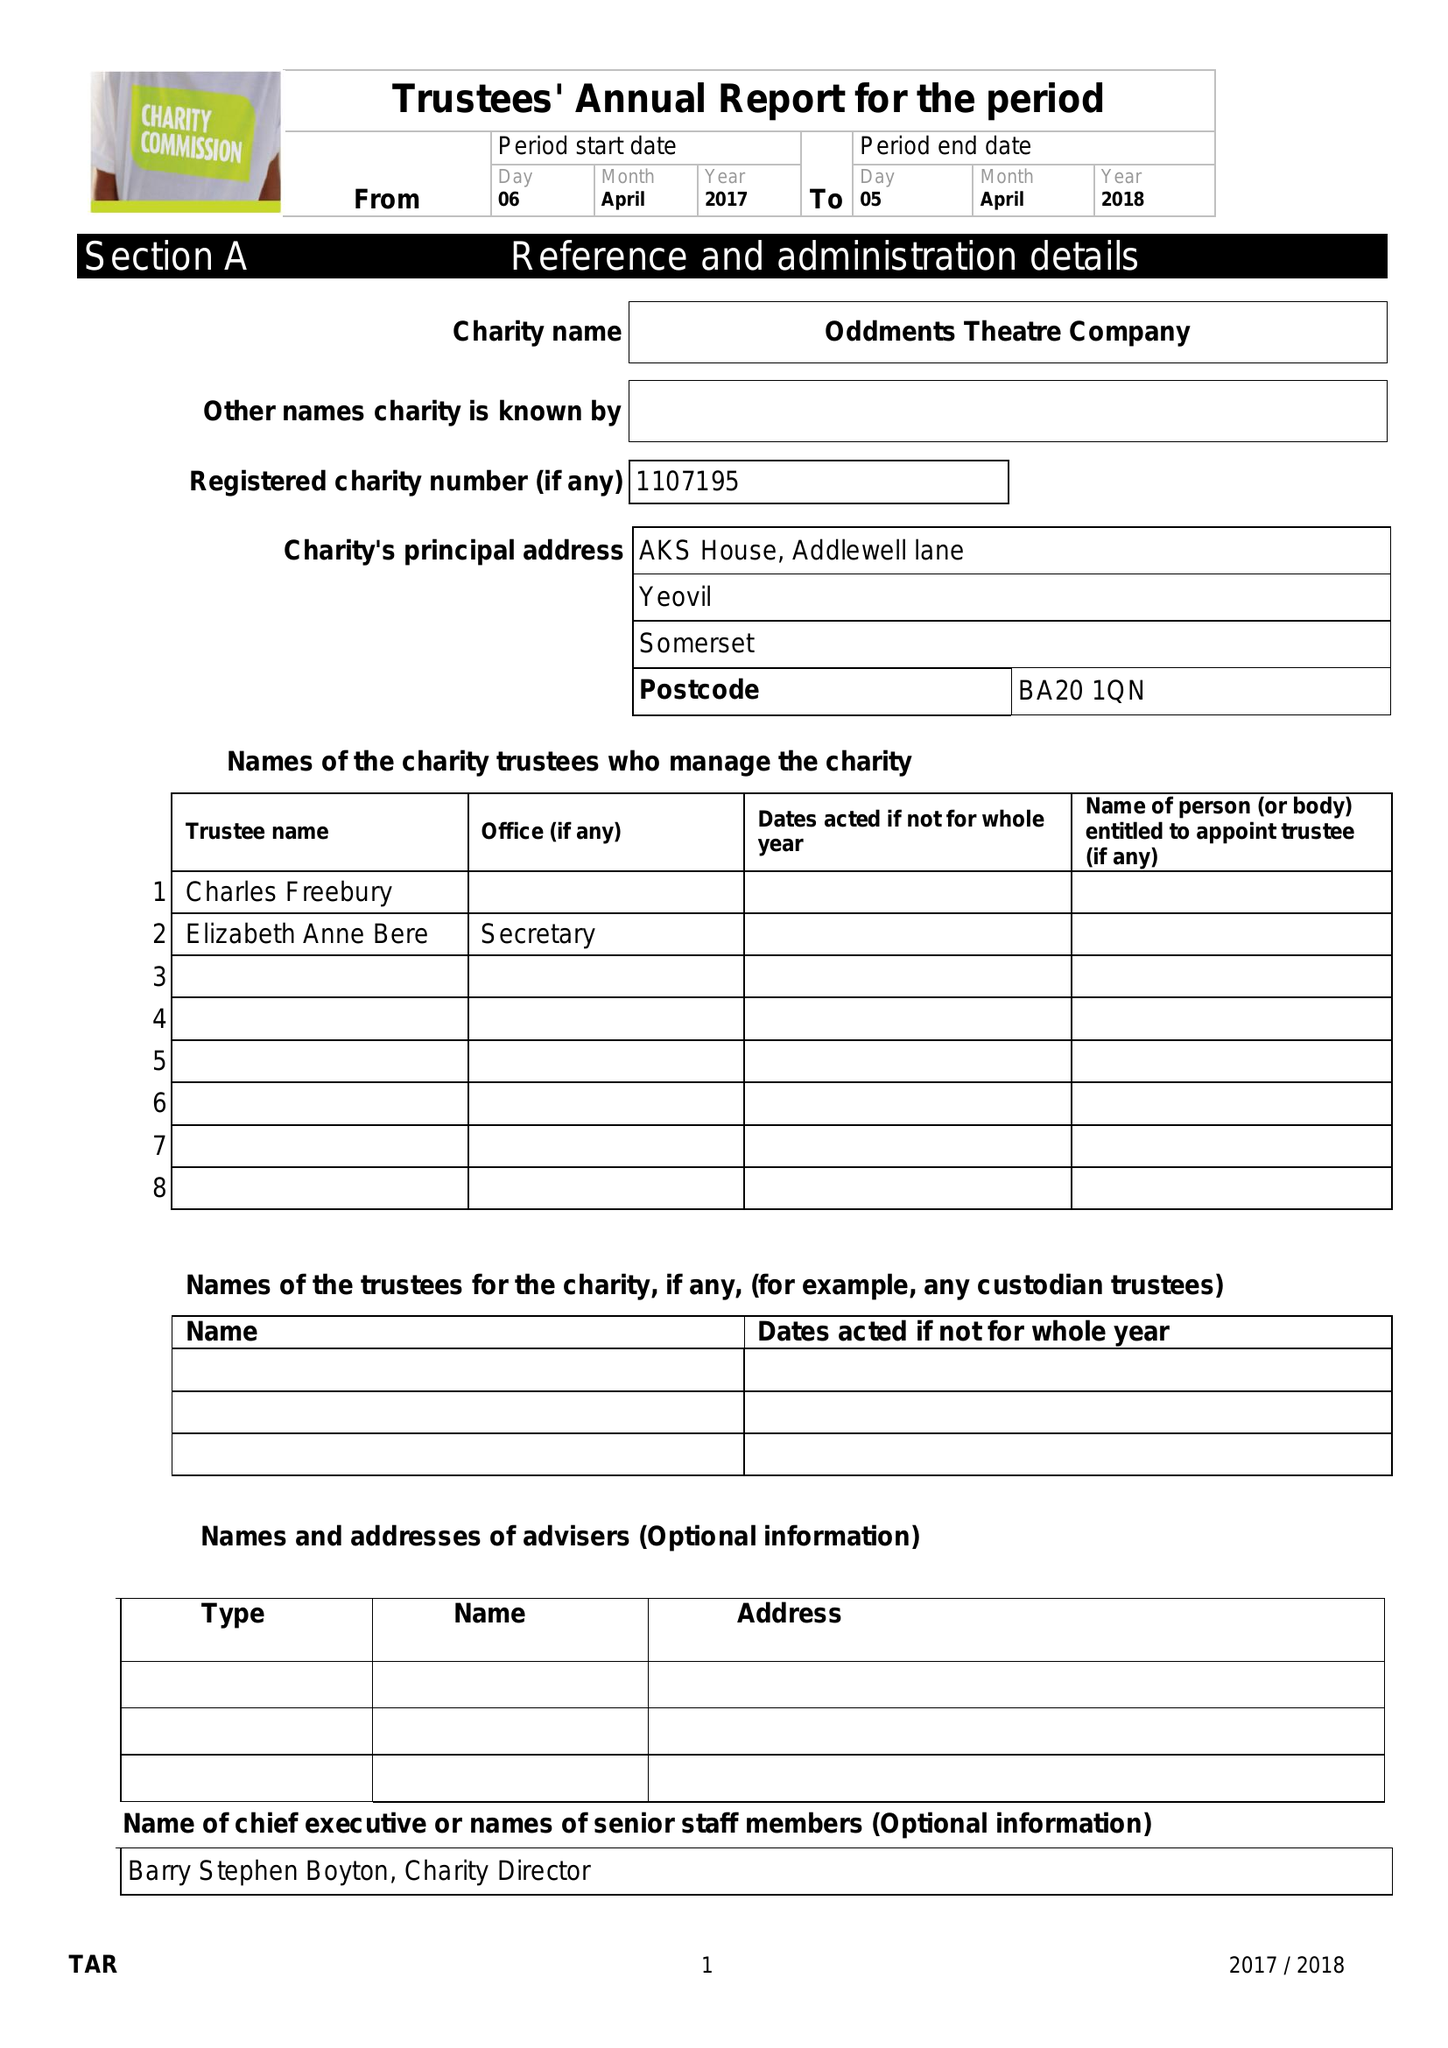What is the value for the spending_annually_in_british_pounds?
Answer the question using a single word or phrase. 119655.00 